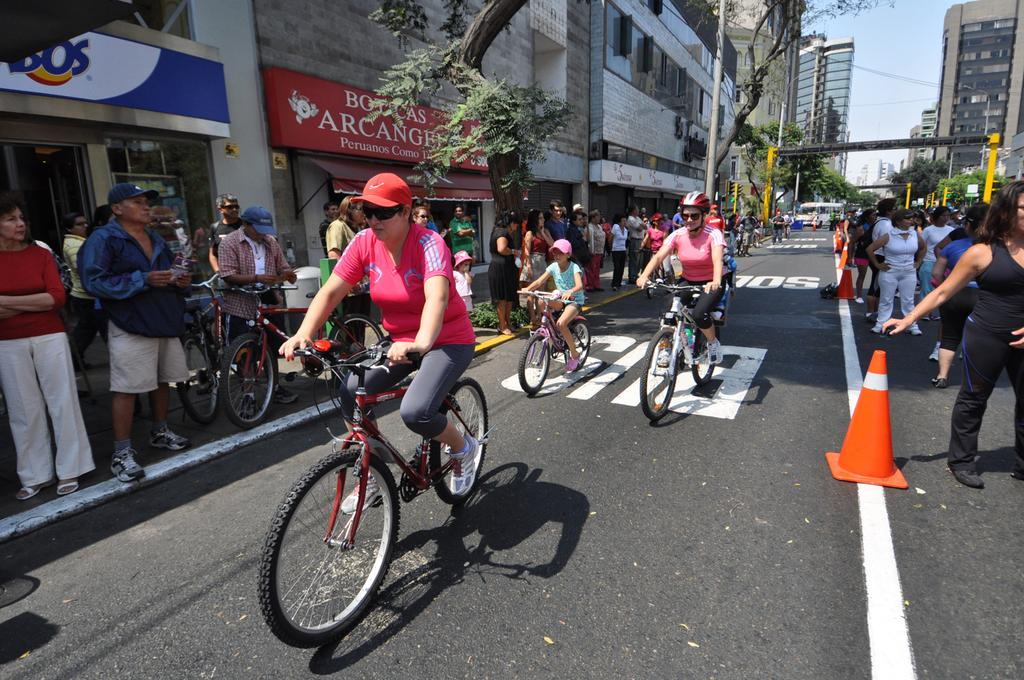What activity are the people in the image engaged in? There is a group of people riding bicycles in the image. Are there any spectators in the image? Yes, there is a group of people watching the bicycle riders. What can be seen in the background of the image? There are buildings and trees visible in the image. What type of hat is the bicycle rider wearing in the image? There is no hat mentioned or visible in the image; the focus is on the bicycle riders and spectators. 